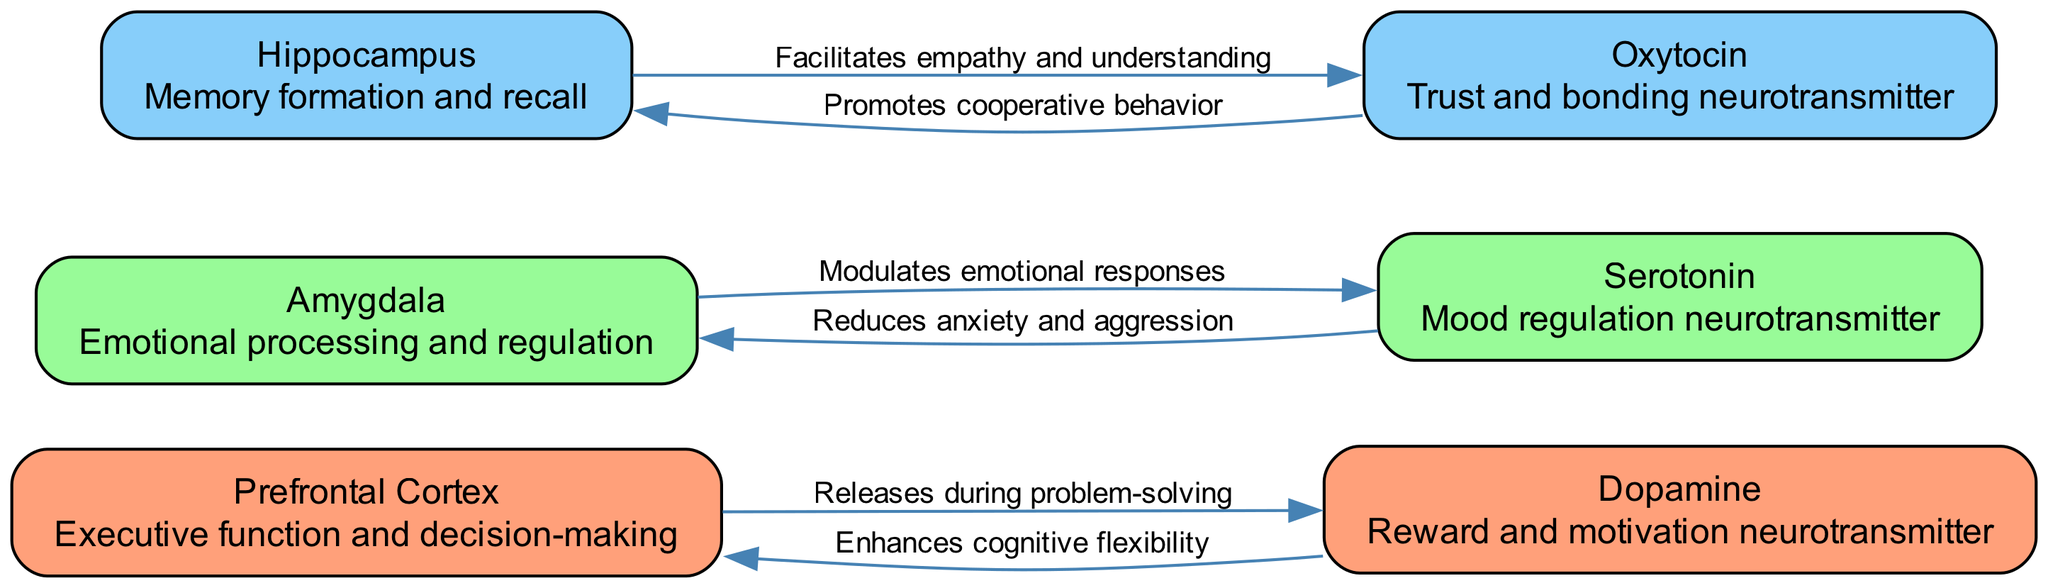What is the primary function of the Prefrontal Cortex? The diagram indicates that the Prefrontal Cortex is associated with "Executive function and decision-making," which directly describes its role.
Answer: Executive function and decision-making How many nodes are present in the diagram? By counting the nodes listed in the data, there are a total of six unique nodes represented in the diagram.
Answer: 6 Which neurotransmitter is linked to trust and bonding? The diagram specifies that Oxytocin is the neurotransmitter that is responsible for "Trust and bonding." This points directly to its connection.
Answer: Oxytocin What effect does Serotonin have on emotional responses? The diagram illustrates that Serotonin "Reduces anxiety and aggression," indicating its calming effect on emotional responses.
Answer: Reduces anxiety and aggression What does the Hippocampus facilitate during conflict resolution? According to the diagram, the Hippocampus "Facilitates empathy and understanding," which aids in navigating conflicts peacefully.
Answer: Facilitates empathy and understanding Which neurotransmitter enhances cognitive flexibility? The diagram establishes that Dopamine is responsible for "Enhances cognitive flexibility," making it vital for effective problem-solving and adaptation during conflict resolution.
Answer: Enhances cognitive flexibility Which node is directly impacted by the release of Serotonin? The diagram shows that Serotonin "Modulates emotional responses," which indicates that it directly affects the Amygdala and its emotional regulation functions.
Answer: Amygdala How does Oxytocin influence cooperative behavior? The flow from the diagram clarifies that Oxytocin "Promotes cooperative behavior" by facilitating a sense of bonding and mutual understanding, vital during negotiations.
Answer: Promotes cooperative behavior What relationship exists between Dopamine and the Prefrontal Cortex? The diagram illustrates a bidirectional relationship where Dopamine "Releases during problem-solving" and "Enhances cognitive flexibility" in the Prefrontal Cortex.
Answer: Enhances cognitive flexibility 